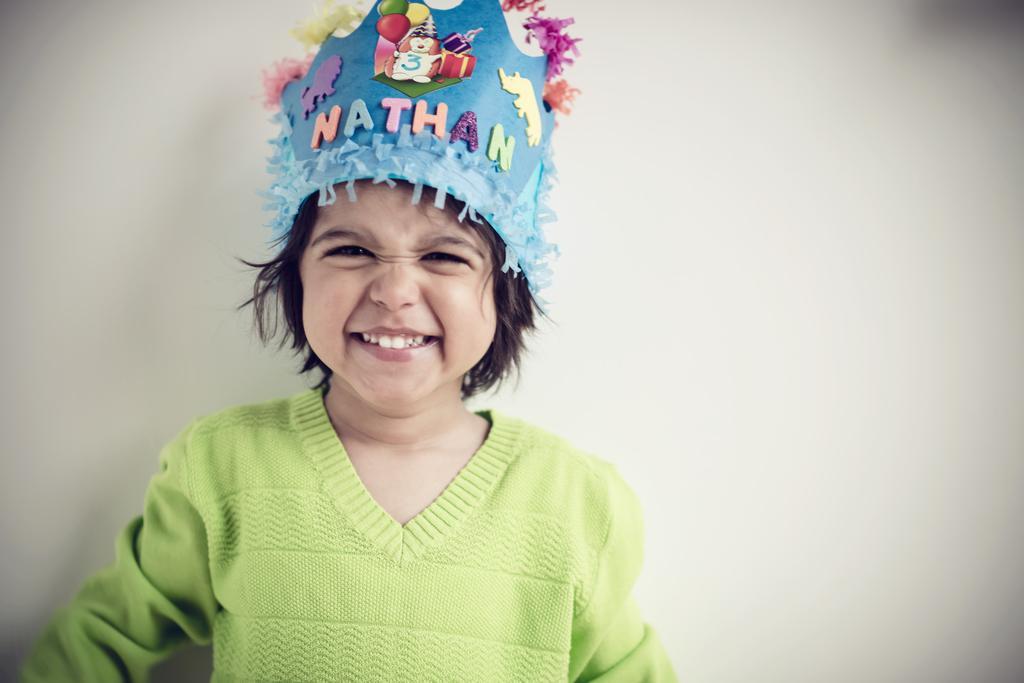Can you describe this image briefly? In this image there is a girl standing, she is wearing a cap, there is text on the cap, at the background of the image there is the wall. 